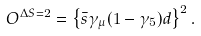Convert formula to latex. <formula><loc_0><loc_0><loc_500><loc_500>O ^ { \Delta S = 2 } = \left \{ \bar { s } \gamma _ { \mu } ( 1 - \gamma _ { 5 } ) d \right \} ^ { 2 } .</formula> 